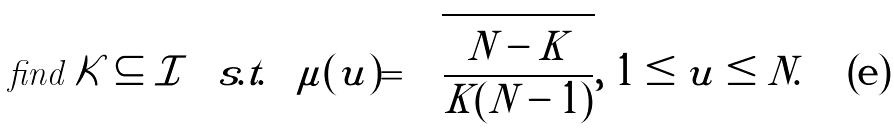<formula> <loc_0><loc_0><loc_500><loc_500>\text {find } \mathcal { K } \subseteq \mathcal { I } \quad s . t . \quad \mu ( u ) = \sqrt { \frac { N - K } { K ( N - 1 ) } } , \ 1 \leq u \leq N .</formula> 